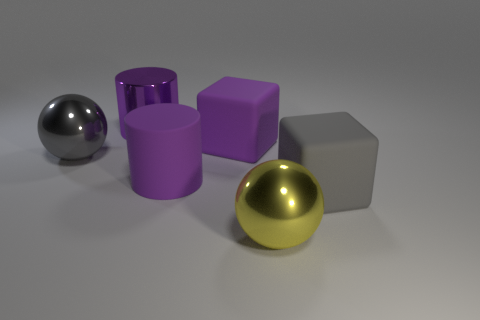Add 2 large metal cylinders. How many objects exist? 8 Subtract all spheres. How many objects are left? 4 Subtract all small green rubber balls. Subtract all gray shiny things. How many objects are left? 5 Add 3 big matte cubes. How many big matte cubes are left? 5 Add 5 large yellow matte cylinders. How many large yellow matte cylinders exist? 5 Subtract 0 red balls. How many objects are left? 6 